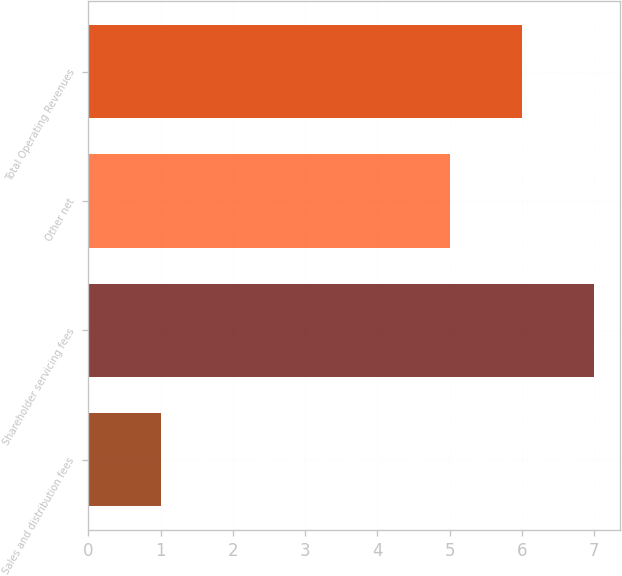Convert chart. <chart><loc_0><loc_0><loc_500><loc_500><bar_chart><fcel>Sales and distribution fees<fcel>Shareholder servicing fees<fcel>Other net<fcel>Total Operating Revenues<nl><fcel>1<fcel>7<fcel>5<fcel>6<nl></chart> 